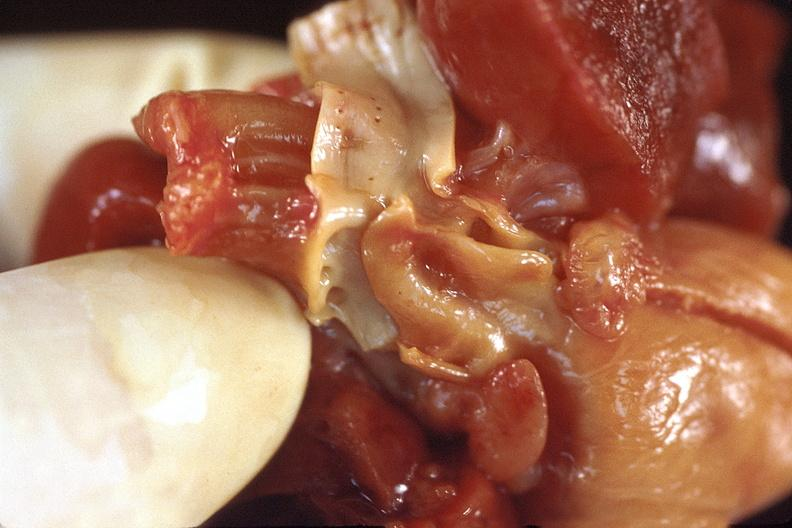does papillary intraductal adenocarcinoma show heart, patent ductus arteriosis in a pateint with hyaline membrane disease?
Answer the question using a single word or phrase. No 